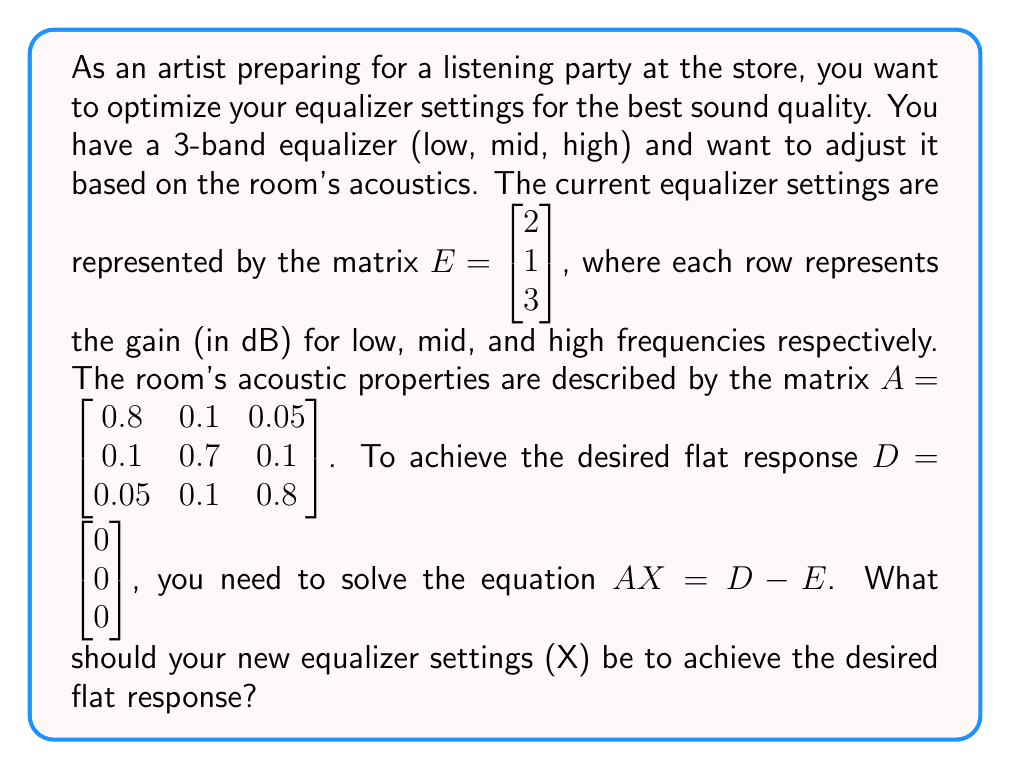What is the answer to this math problem? To solve this problem, we need to use matrix operations and solve a system of linear equations. Let's break it down step by step:

1) We start with the equation $AX = D - E$

2) First, let's calculate $D - E$:
   $D - E = \begin{bmatrix} 0 \\ 0 \\ 0 \end{bmatrix} - \begin{bmatrix} 2 \\ 1 \\ 3 \end{bmatrix} = \begin{bmatrix} -2 \\ -1 \\ -3 \end{bmatrix}$

3) Now our equation looks like:
   $A X = \begin{bmatrix} -2 \\ -1 \\ -3 \end{bmatrix}$

4) To solve for X, we need to multiply both sides by the inverse of A:
   $A^{-1}A X = A^{-1}\begin{bmatrix} -2 \\ -1 \\ -3 \end{bmatrix}$
   $X = A^{-1}\begin{bmatrix} -2 \\ -1 \\ -3 \end{bmatrix}$

5) Let's calculate the inverse of A:
   $A^{-1} = \begin{bmatrix} 1.3245 & -0.1887 & -0.0943 \\ -0.1887 & 1.5094 & -0.1887 \\ -0.0943 & -0.1887 & 1.3245 \end{bmatrix}$

6) Now we can multiply:
   $X = \begin{bmatrix} 1.3245 & -0.1887 & -0.0943 \\ -0.1887 & 1.5094 & -0.1887 \\ -0.0943 & -0.1887 & 1.3245 \end{bmatrix} \begin{bmatrix} -2 \\ -1 \\ -3 \end{bmatrix}$

7) Performing the matrix multiplication:
   $X = \begin{bmatrix} -2.6490 + 0.1887 + 0.2829 \\ 0.3774 - 1.5094 + 0.5661 \\ 0.1886 + 0.1887 - 3.9735 \end{bmatrix} = \begin{bmatrix} -2.1774 \\ -0.5659 \\ -3.5962 \end{bmatrix}$

8) Rounding to two decimal places for practical equalizer settings:
   $X \approx \begin{bmatrix} -2.18 \\ -0.57 \\ -3.60 \end{bmatrix}$

These values represent the adjustments (in dB) you need to make to your current equalizer settings to achieve a flat response in the given acoustic environment.
Answer: The new equalizer settings should be approximately:
$$X = \begin{bmatrix} -2.18 \\ -0.57 \\ -3.60 \end{bmatrix}$$
This means you should decrease the low frequencies by 2.18 dB, the mid frequencies by 0.57 dB, and the high frequencies by 3.60 dB from your current settings. 